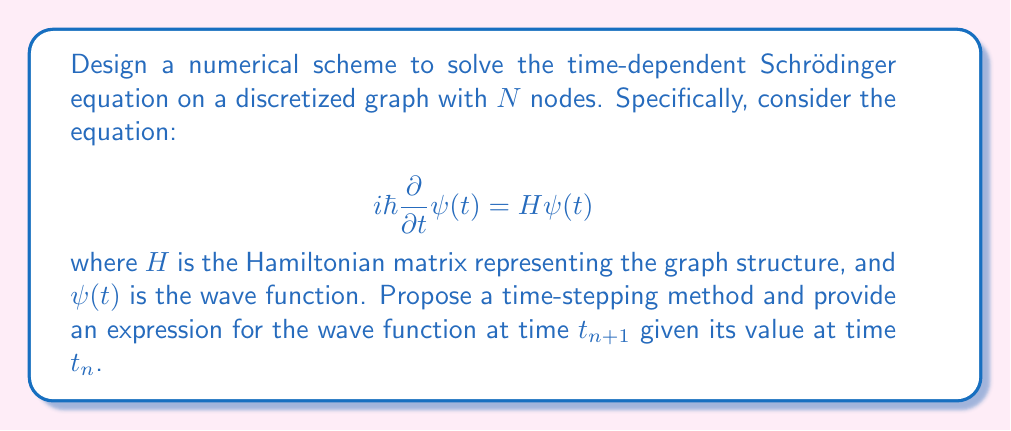Solve this math problem. To solve this problem, we can use the Crank-Nicolson method, which is an implicit second-order method that preserves the norm of the wave function. Here's the step-by-step approach:

1) First, we discretize time into small steps $\Delta t$, such that $t_n = n\Delta t$.

2) The Crank-Nicolson method approximates the Schrödinger equation as:

   $$i\hbar\frac{\psi(t_{n+1}) - \psi(t_n)}{\Delta t} = \frac{1}{2}H[\psi(t_{n+1}) + \psi(t_n)]$$

3) Rearranging the terms:

   $$\left(i\hbar I + \frac{\Delta t}{2}H\right)\psi(t_{n+1}) = \left(i\hbar I - \frac{\Delta t}{2}H\right)\psi(t_n)$$

   where $I$ is the $N \times N$ identity matrix.

4) Define matrices $A$ and $B$:

   $$A = i\hbar I + \frac{\Delta t}{2}H$$
   $$B = i\hbar I - \frac{\Delta t}{2}H$$

5) The update equation becomes:

   $$A\psi(t_{n+1}) = B\psi(t_n)$$

6) To solve for $\psi(t_{n+1})$, we need to invert matrix $A$:

   $$\psi(t_{n+1}) = A^{-1}B\psi(t_n)$$

7) Define the time evolution operator $U = A^{-1}B$. Then the final update equation is:

   $$\psi(t_{n+1}) = U\psi(t_n)$$

This method is unconditionally stable and preserves the norm of the wave function, making it suitable for quantum systems on graphs.
Answer: $\psi(t_{n+1}) = \left(i\hbar I + \frac{\Delta t}{2}H\right)^{-1}\left(i\hbar I - \frac{\Delta t}{2}H\right)\psi(t_n)$ 